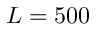<formula> <loc_0><loc_0><loc_500><loc_500>L = 5 0 0</formula> 